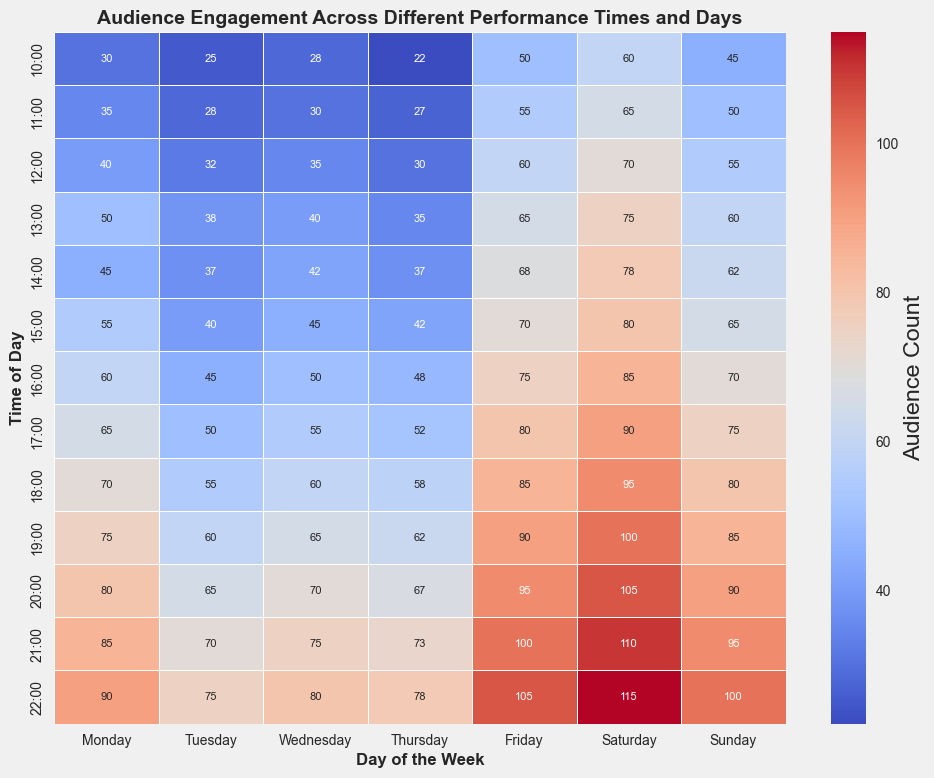What is the most engaged time slot on Saturday? To find the most engaged time slot on Saturday, look at the 'Saturday' column and identify the highest number. The highest number in the Saturday column is 115 at 22:00.
Answer: 22:00 Which day has the least audience engagement at 14:00? To find the day with the least audience engagement at 14:00, look at the 14:00 row and identify the smallest number. 'Thursday' has 37, which is the smallest number.
Answer: Thursday What is the average audience engagement on Thursday at 19:00 and 20:00? To find the average, first add the audience counts for Thursday at 19:00 and 20:00. The values are 62 and 67 respectively. (62 + 67) = 129. Then divide by 2. 129 / 2 = 64.5
Answer: 64.5 How does the audience count at 18:00 on Friday compare to that on Sunday at the same time? Compare the values at 18:00 for Friday and Sunday. Friday has 85 and Sunday has 80. 85 is greater than 80.
Answer: Friday > Sunday Which hour has the most consistent audience engagement across all days? To find the most consistent hour, look at each time slot row and identify which has the least variability in numbers. The 14:00 row ranges from 37 to 78, which shows a mid-level spread for all days, indicating relatively less variability in distribution.
Answer: 14:00 What is the difference in audience count between the peak time on Monday and the peak time on Sunday? Find the peak times for Monday and Sunday and then their difference. The peak for Monday is 90 at 22:00, and the peak for Sunday is 100 at 22:00. So, 100 - 90 = 10.
Answer: 10 On which day is the 16:00 audience count the highest? Compare the audience counts at 16:00 across all days. The highest number is 85 on Saturday.
Answer: Saturday What is the total audience engagement on Wednesday between 17:00 and 19:00? Add the audience counts for Wednesday from 17:00 to 19:00. The values are 55, 60, and 65. (55 + 60 + 65) = 180.
Answer: 180 Which two consecutive hours on Friday have the greatest increase in audience count? Compute the difference between consecutive hours on Friday and identify the greatest positive change. The increase from 16:00 to 17:00 (75 to 80) is 5, but from 18:00 to 19:00 it's (85 to 90), which is also 5. However, the largest change is from 21:00 to 22:00 (100 to 105), which is an increase of 10.
Answer: 21:00 to 22:00 What is the sum of audience counts at 10:00 across all days? Sum the audience counts for 10:00 across all days. The values are 30, 25, 28, 22, 50, 60, and 45. (30 + 25 + 28 + 22 + 50 + 60 + 45) = 260.
Answer: 260 